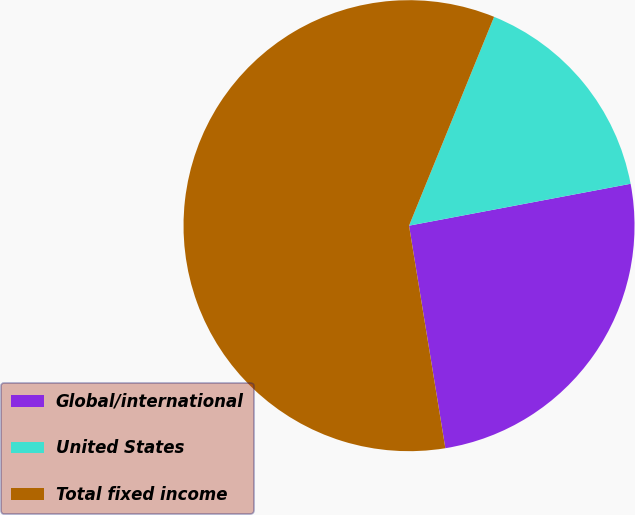Convert chart. <chart><loc_0><loc_0><loc_500><loc_500><pie_chart><fcel>Global/international<fcel>United States<fcel>Total fixed income<nl><fcel>25.4%<fcel>15.87%<fcel>58.73%<nl></chart> 